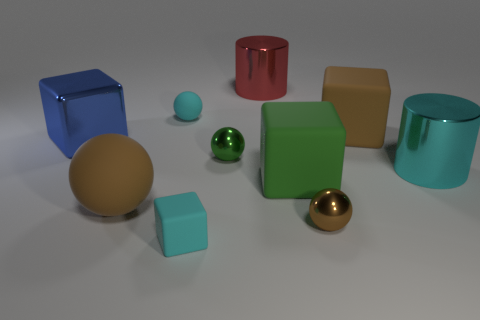Subtract all gray blocks. Subtract all blue cylinders. How many blocks are left? 4 Subtract all cubes. How many objects are left? 6 Subtract all big brown metallic balls. Subtract all small green metal objects. How many objects are left? 9 Add 5 green shiny things. How many green shiny things are left? 6 Add 4 large objects. How many large objects exist? 10 Subtract 0 yellow blocks. How many objects are left? 10 